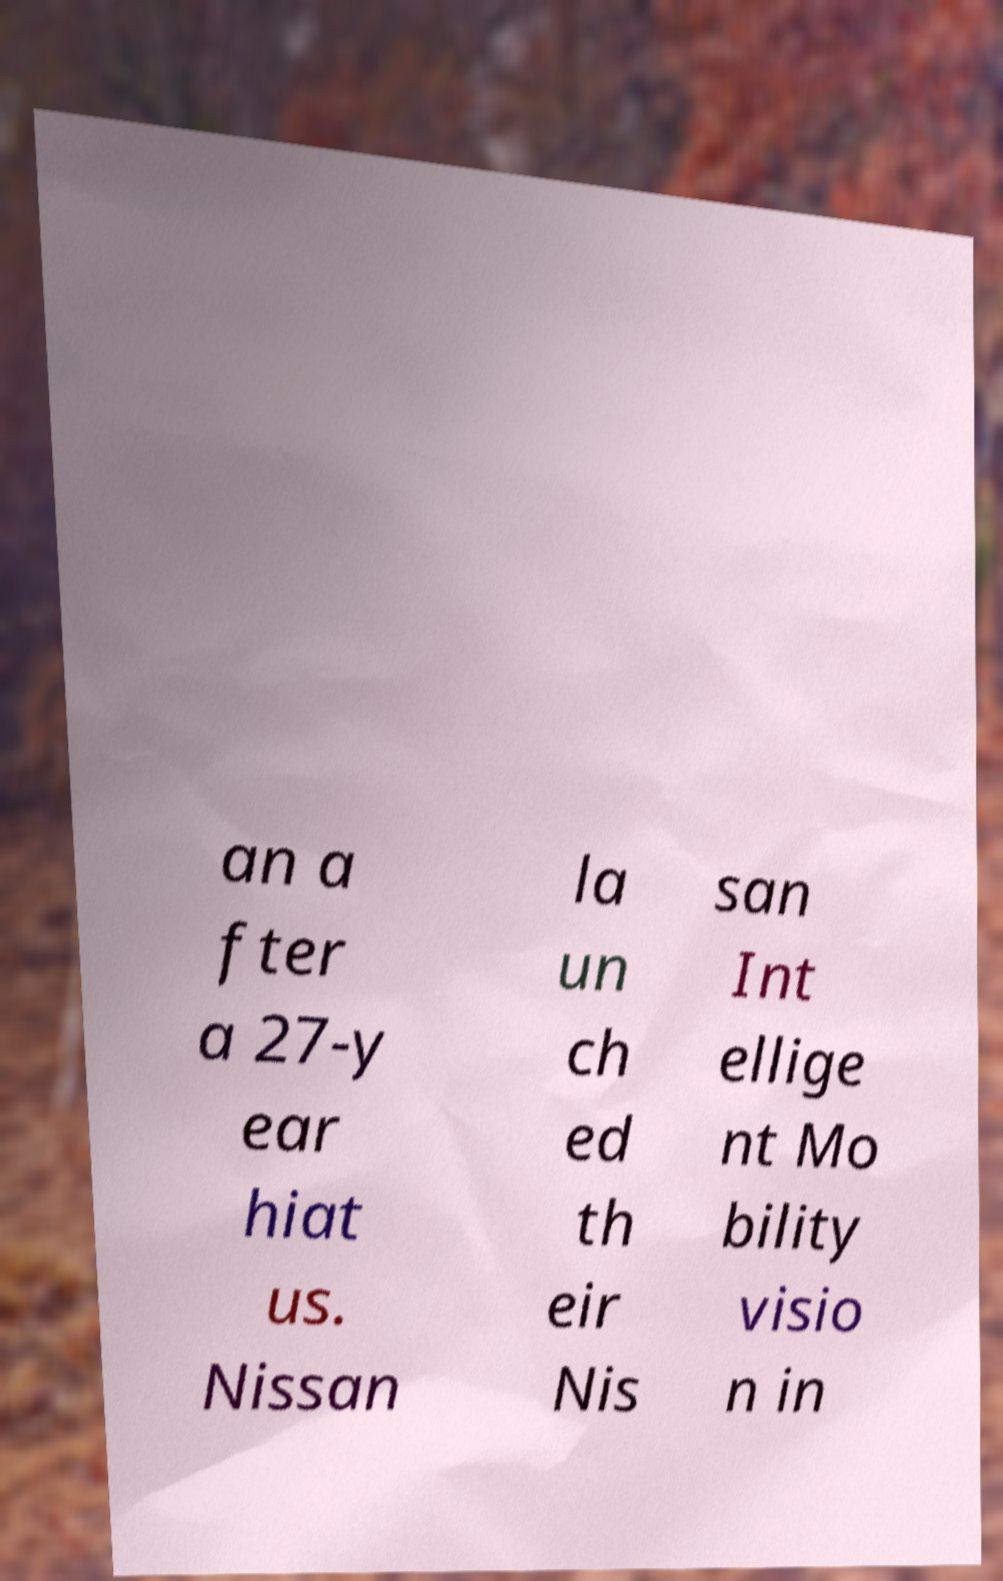I need the written content from this picture converted into text. Can you do that? an a fter a 27-y ear hiat us. Nissan la un ch ed th eir Nis san Int ellige nt Mo bility visio n in 